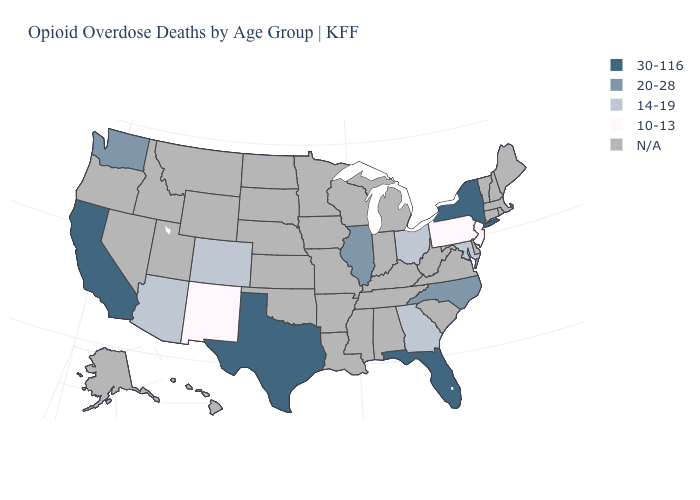What is the value of Rhode Island?
Quick response, please. N/A. Name the states that have a value in the range 14-19?
Concise answer only. Arizona, Colorado, Georgia, Maryland, Ohio. Does the map have missing data?
Give a very brief answer. Yes. What is the highest value in the USA?
Short answer required. 30-116. What is the value of Nevada?
Answer briefly. N/A. Name the states that have a value in the range 14-19?
Be succinct. Arizona, Colorado, Georgia, Maryland, Ohio. What is the lowest value in states that border Connecticut?
Quick response, please. 30-116. Is the legend a continuous bar?
Write a very short answer. No. What is the highest value in the USA?
Give a very brief answer. 30-116. What is the highest value in the West ?
Write a very short answer. 30-116. Is the legend a continuous bar?
Quick response, please. No. What is the value of Delaware?
Quick response, please. N/A. Does California have the lowest value in the West?
Keep it brief. No. Name the states that have a value in the range 14-19?
Answer briefly. Arizona, Colorado, Georgia, Maryland, Ohio. 